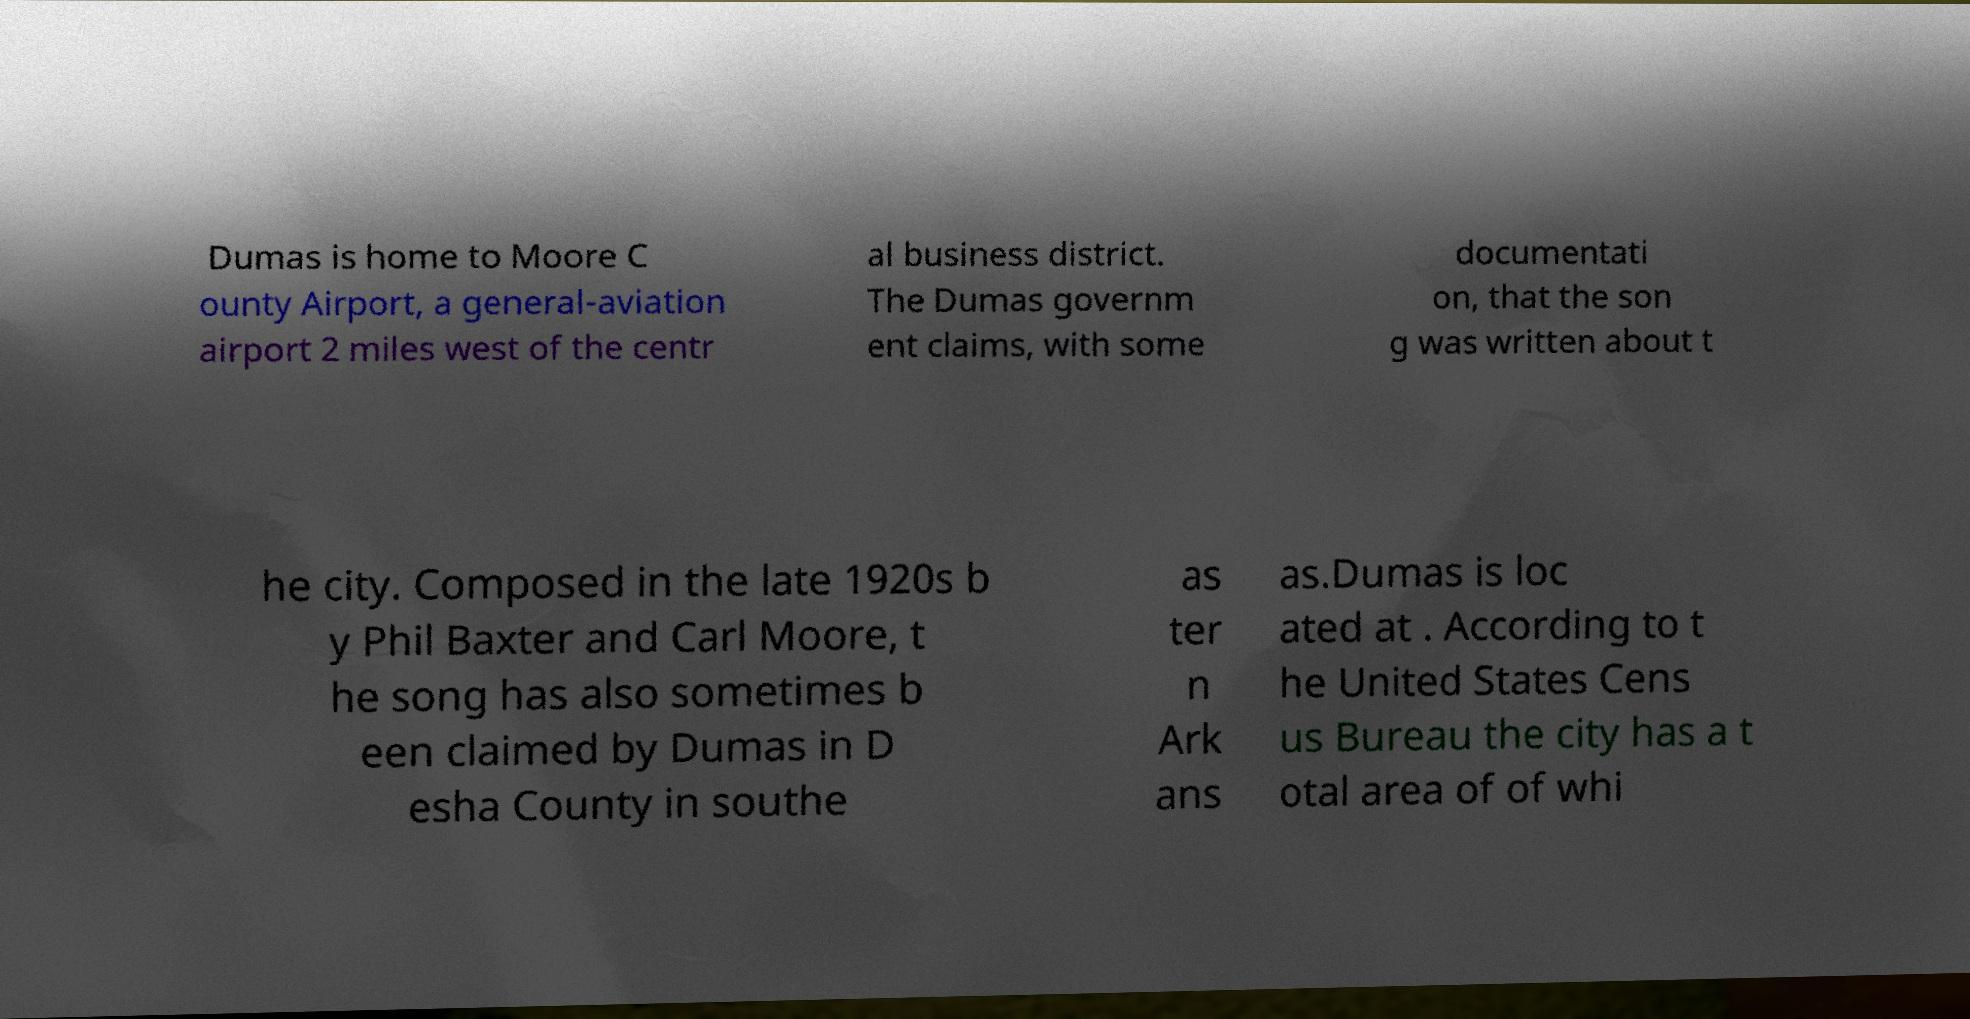Please read and relay the text visible in this image. What does it say? Dumas is home to Moore C ounty Airport, a general-aviation airport 2 miles west of the centr al business district. The Dumas governm ent claims, with some documentati on, that the son g was written about t he city. Composed in the late 1920s b y Phil Baxter and Carl Moore, t he song has also sometimes b een claimed by Dumas in D esha County in southe as ter n Ark ans as.Dumas is loc ated at . According to t he United States Cens us Bureau the city has a t otal area of of whi 